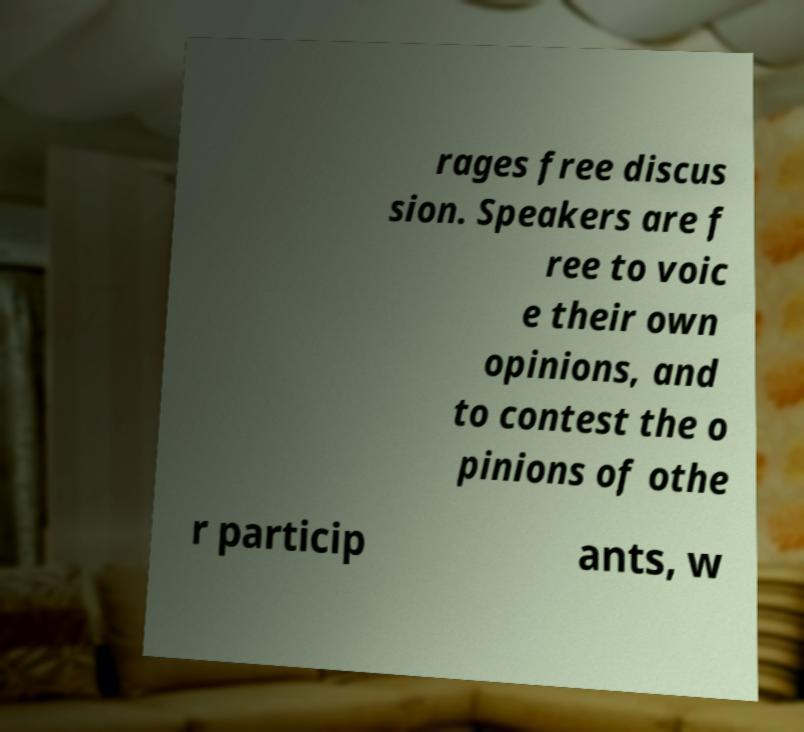Can you read and provide the text displayed in the image?This photo seems to have some interesting text. Can you extract and type it out for me? rages free discus sion. Speakers are f ree to voic e their own opinions, and to contest the o pinions of othe r particip ants, w 